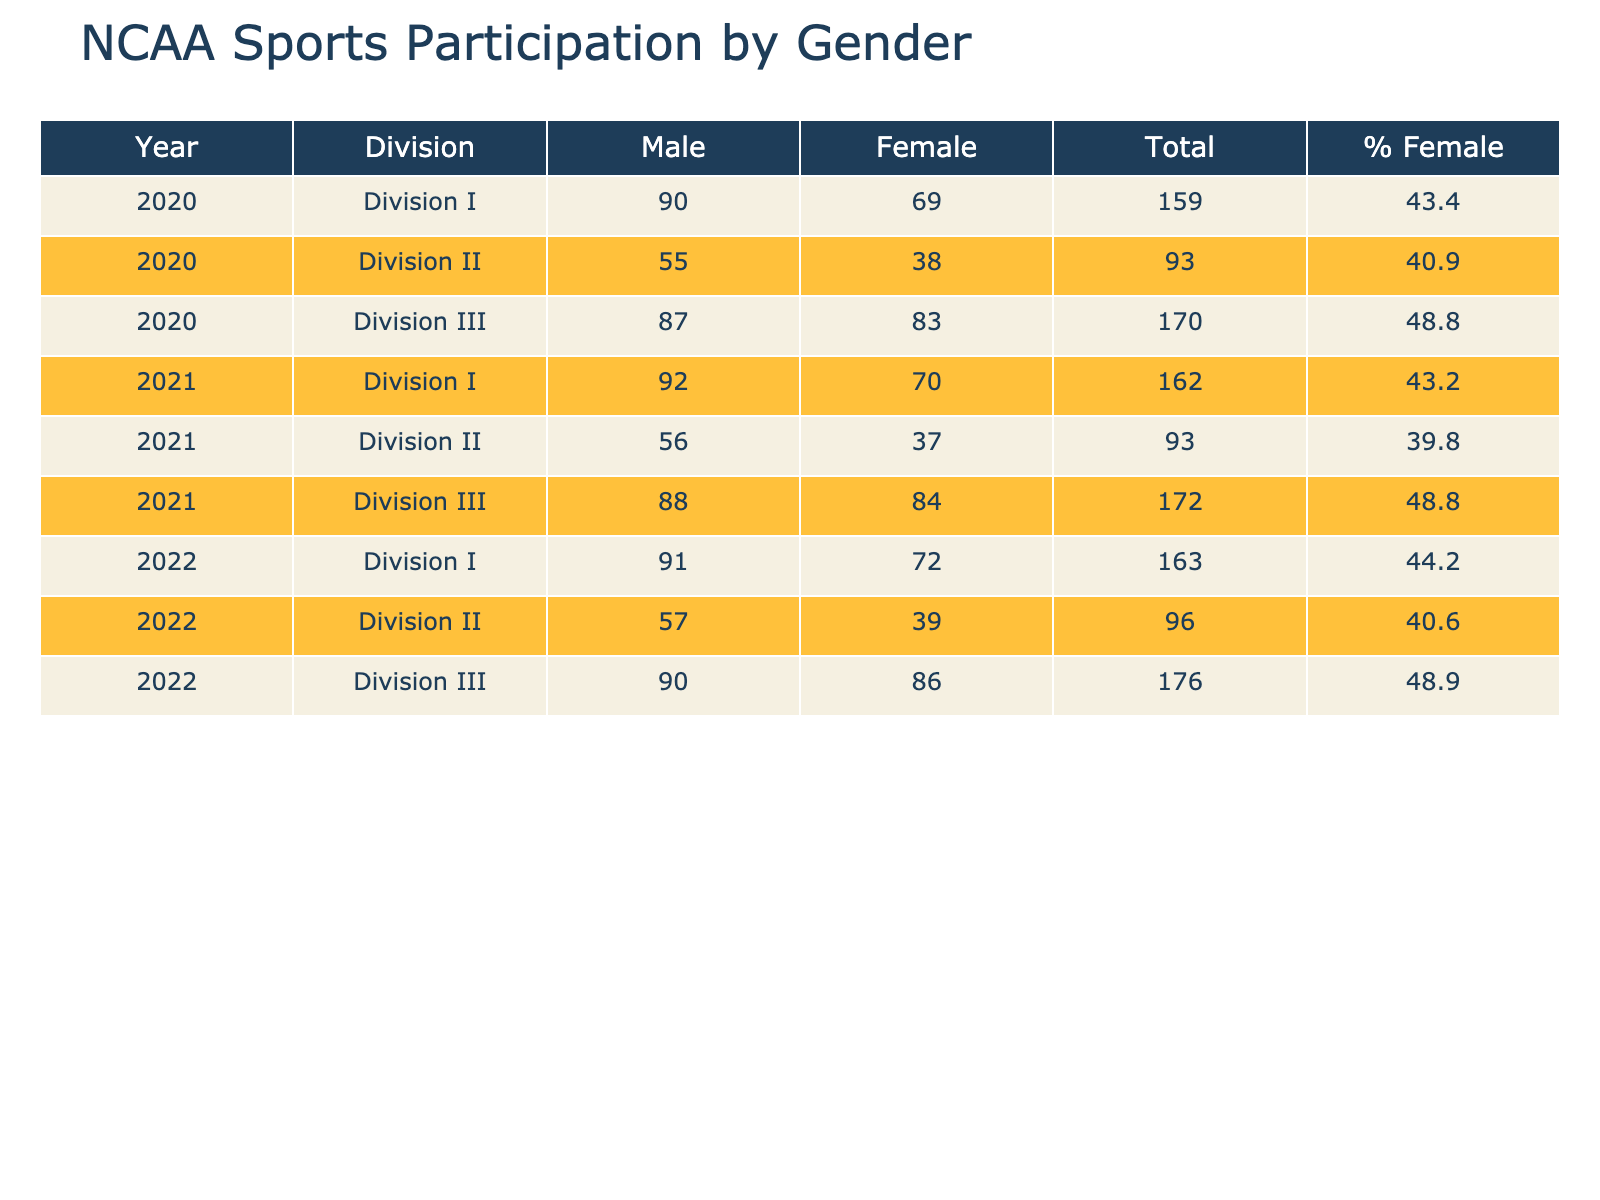What was the total number of male athletes in Division II for 2021? In the year 2021, for Division II, the row under Male shows a participant count of 56.
Answer: 56 What is the percentage of female athletes in Division I in 2022? In 2022 for Division I, the total participant count is 91 (male) + 72 (female) = 163. The female count is 72. The percentage is calculated as (72/163) * 100 = 44.2%.
Answer: 44.2% Did the number of female athletes in Division III increase from 2020 to 2022? In Division III, the female athlete counts were 83 in 2020 and 86 in 2022, indicating an increase of 3 athletes.
Answer: Yes What is the average number of male athletes across all divisions for 2020? Adding the male participants for each division: 90 (I) + 55 (II) + 87 (III) = 232. There are 3 divisions; thus, the average is 232/3 ≈ 77.33.
Answer: 77.33 Was there a decrease in the number of female participants in Division II from 2020 to 2021? In Division II, female participants were 38 in 2020 and dropped to 37 in 2021, which corresponds to a decrease of 1 athlete.
Answer: Yes How many total participants were there in Division I in 2021? For Division I in 2021, the male participants are 92 and female are 70. The total count is 92 + 70 = 162.
Answer: 162 Which division had the highest percentage of female athletes in 2022? Calculate the percentages for each division in 2022: Division I: 72/163*100 = 44.2%; Division II: 39/(57+39)*100 = 40.6%; Division III: 86/(90+86)*100 = 48.8%. Division III has the highest percentage at 48.8%.
Answer: Division III Is it true that the number of female participants in Division I was higher than that in Division II every year from 2020 to 2022? Check each year: 2020: 69 (I) > 38 (II), 2021: 70 (I) > 37 (II), and 2022: 72 (I) > 39 (II). Each comparison shows that female participants in Division I were consistently higher than in Division II.
Answer: Yes 